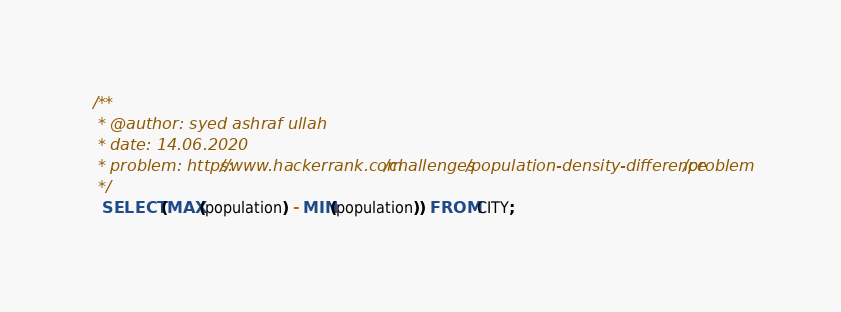Convert code to text. <code><loc_0><loc_0><loc_500><loc_500><_SQL_>/**
 * @author: syed ashraf ullah
 * date: 14.06.2020
 * problem: https://www.hackerrank.com/challenges/population-density-difference/problem
 */
  SELECT (MAX(population) - MIN(population)) FROM CITY;</code> 